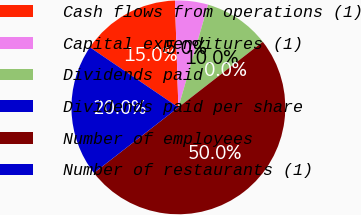Convert chart to OTSL. <chart><loc_0><loc_0><loc_500><loc_500><pie_chart><fcel>Cash flows from operations (1)<fcel>Capital expenditures (1)<fcel>Dividends paid<fcel>Dividends paid per share<fcel>Number of employees<fcel>Number of restaurants (1)<nl><fcel>15.0%<fcel>5.0%<fcel>10.0%<fcel>0.0%<fcel>50.0%<fcel>20.0%<nl></chart> 